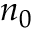Convert formula to latex. <formula><loc_0><loc_0><loc_500><loc_500>n _ { 0 }</formula> 